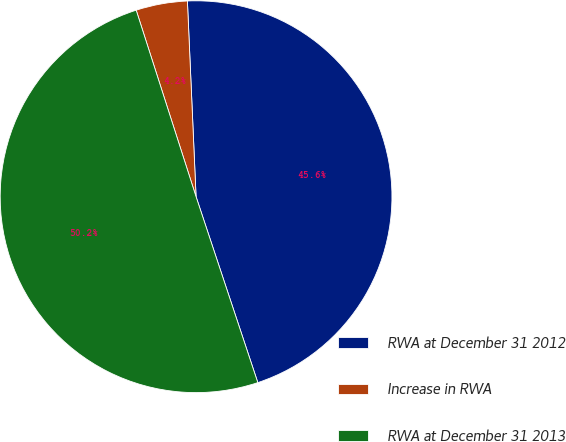<chart> <loc_0><loc_0><loc_500><loc_500><pie_chart><fcel>RWA at December 31 2012<fcel>Increase in RWA<fcel>RWA at December 31 2013<nl><fcel>45.6%<fcel>4.24%<fcel>50.16%<nl></chart> 